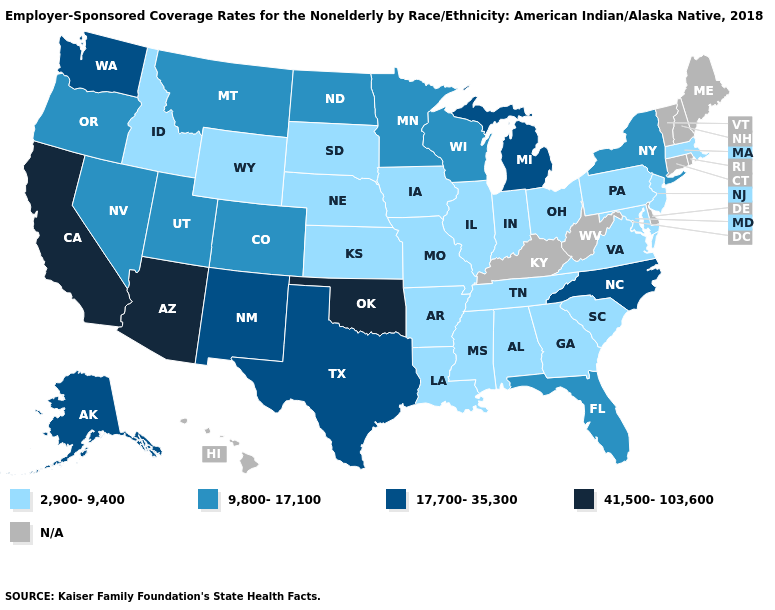What is the lowest value in the USA?
Write a very short answer. 2,900-9,400. What is the value of Alaska?
Answer briefly. 17,700-35,300. Among the states that border Missouri , which have the lowest value?
Be succinct. Arkansas, Illinois, Iowa, Kansas, Nebraska, Tennessee. What is the value of North Dakota?
Quick response, please. 9,800-17,100. What is the lowest value in the South?
Write a very short answer. 2,900-9,400. Name the states that have a value in the range 17,700-35,300?
Keep it brief. Alaska, Michigan, New Mexico, North Carolina, Texas, Washington. Does the map have missing data?
Keep it brief. Yes. What is the value of Iowa?
Quick response, please. 2,900-9,400. What is the highest value in the USA?
Answer briefly. 41,500-103,600. What is the value of Utah?
Be succinct. 9,800-17,100. Name the states that have a value in the range 2,900-9,400?
Short answer required. Alabama, Arkansas, Georgia, Idaho, Illinois, Indiana, Iowa, Kansas, Louisiana, Maryland, Massachusetts, Mississippi, Missouri, Nebraska, New Jersey, Ohio, Pennsylvania, South Carolina, South Dakota, Tennessee, Virginia, Wyoming. Among the states that border Arkansas , which have the highest value?
Be succinct. Oklahoma. What is the highest value in states that border Utah?
Keep it brief. 41,500-103,600. What is the value of Minnesota?
Answer briefly. 9,800-17,100. 